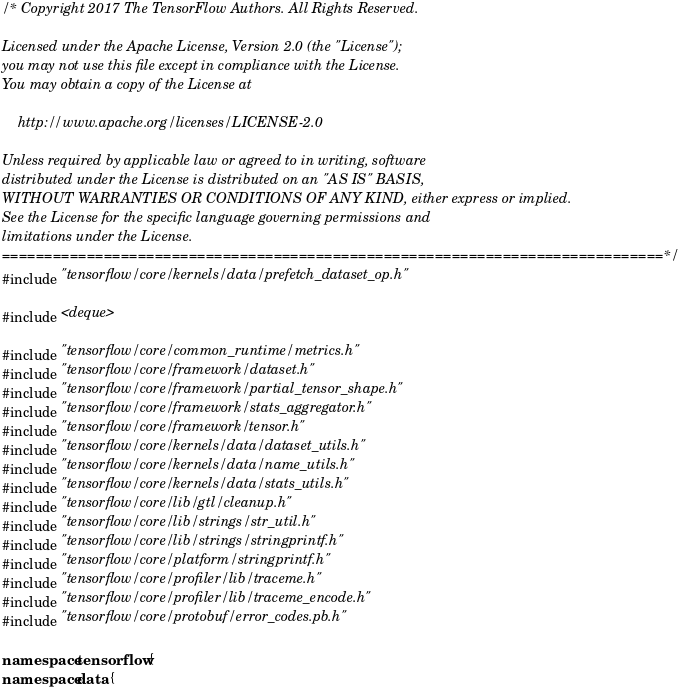Convert code to text. <code><loc_0><loc_0><loc_500><loc_500><_C++_>/* Copyright 2017 The TensorFlow Authors. All Rights Reserved.

Licensed under the Apache License, Version 2.0 (the "License");
you may not use this file except in compliance with the License.
You may obtain a copy of the License at

    http://www.apache.org/licenses/LICENSE-2.0

Unless required by applicable law or agreed to in writing, software
distributed under the License is distributed on an "AS IS" BASIS,
WITHOUT WARRANTIES OR CONDITIONS OF ANY KIND, either express or implied.
See the License for the specific language governing permissions and
limitations under the License.
==============================================================================*/
#include "tensorflow/core/kernels/data/prefetch_dataset_op.h"

#include <deque>

#include "tensorflow/core/common_runtime/metrics.h"
#include "tensorflow/core/framework/dataset.h"
#include "tensorflow/core/framework/partial_tensor_shape.h"
#include "tensorflow/core/framework/stats_aggregator.h"
#include "tensorflow/core/framework/tensor.h"
#include "tensorflow/core/kernels/data/dataset_utils.h"
#include "tensorflow/core/kernels/data/name_utils.h"
#include "tensorflow/core/kernels/data/stats_utils.h"
#include "tensorflow/core/lib/gtl/cleanup.h"
#include "tensorflow/core/lib/strings/str_util.h"
#include "tensorflow/core/lib/strings/stringprintf.h"
#include "tensorflow/core/platform/stringprintf.h"
#include "tensorflow/core/profiler/lib/traceme.h"
#include "tensorflow/core/profiler/lib/traceme_encode.h"
#include "tensorflow/core/protobuf/error_codes.pb.h"

namespace tensorflow {
namespace data {
</code> 